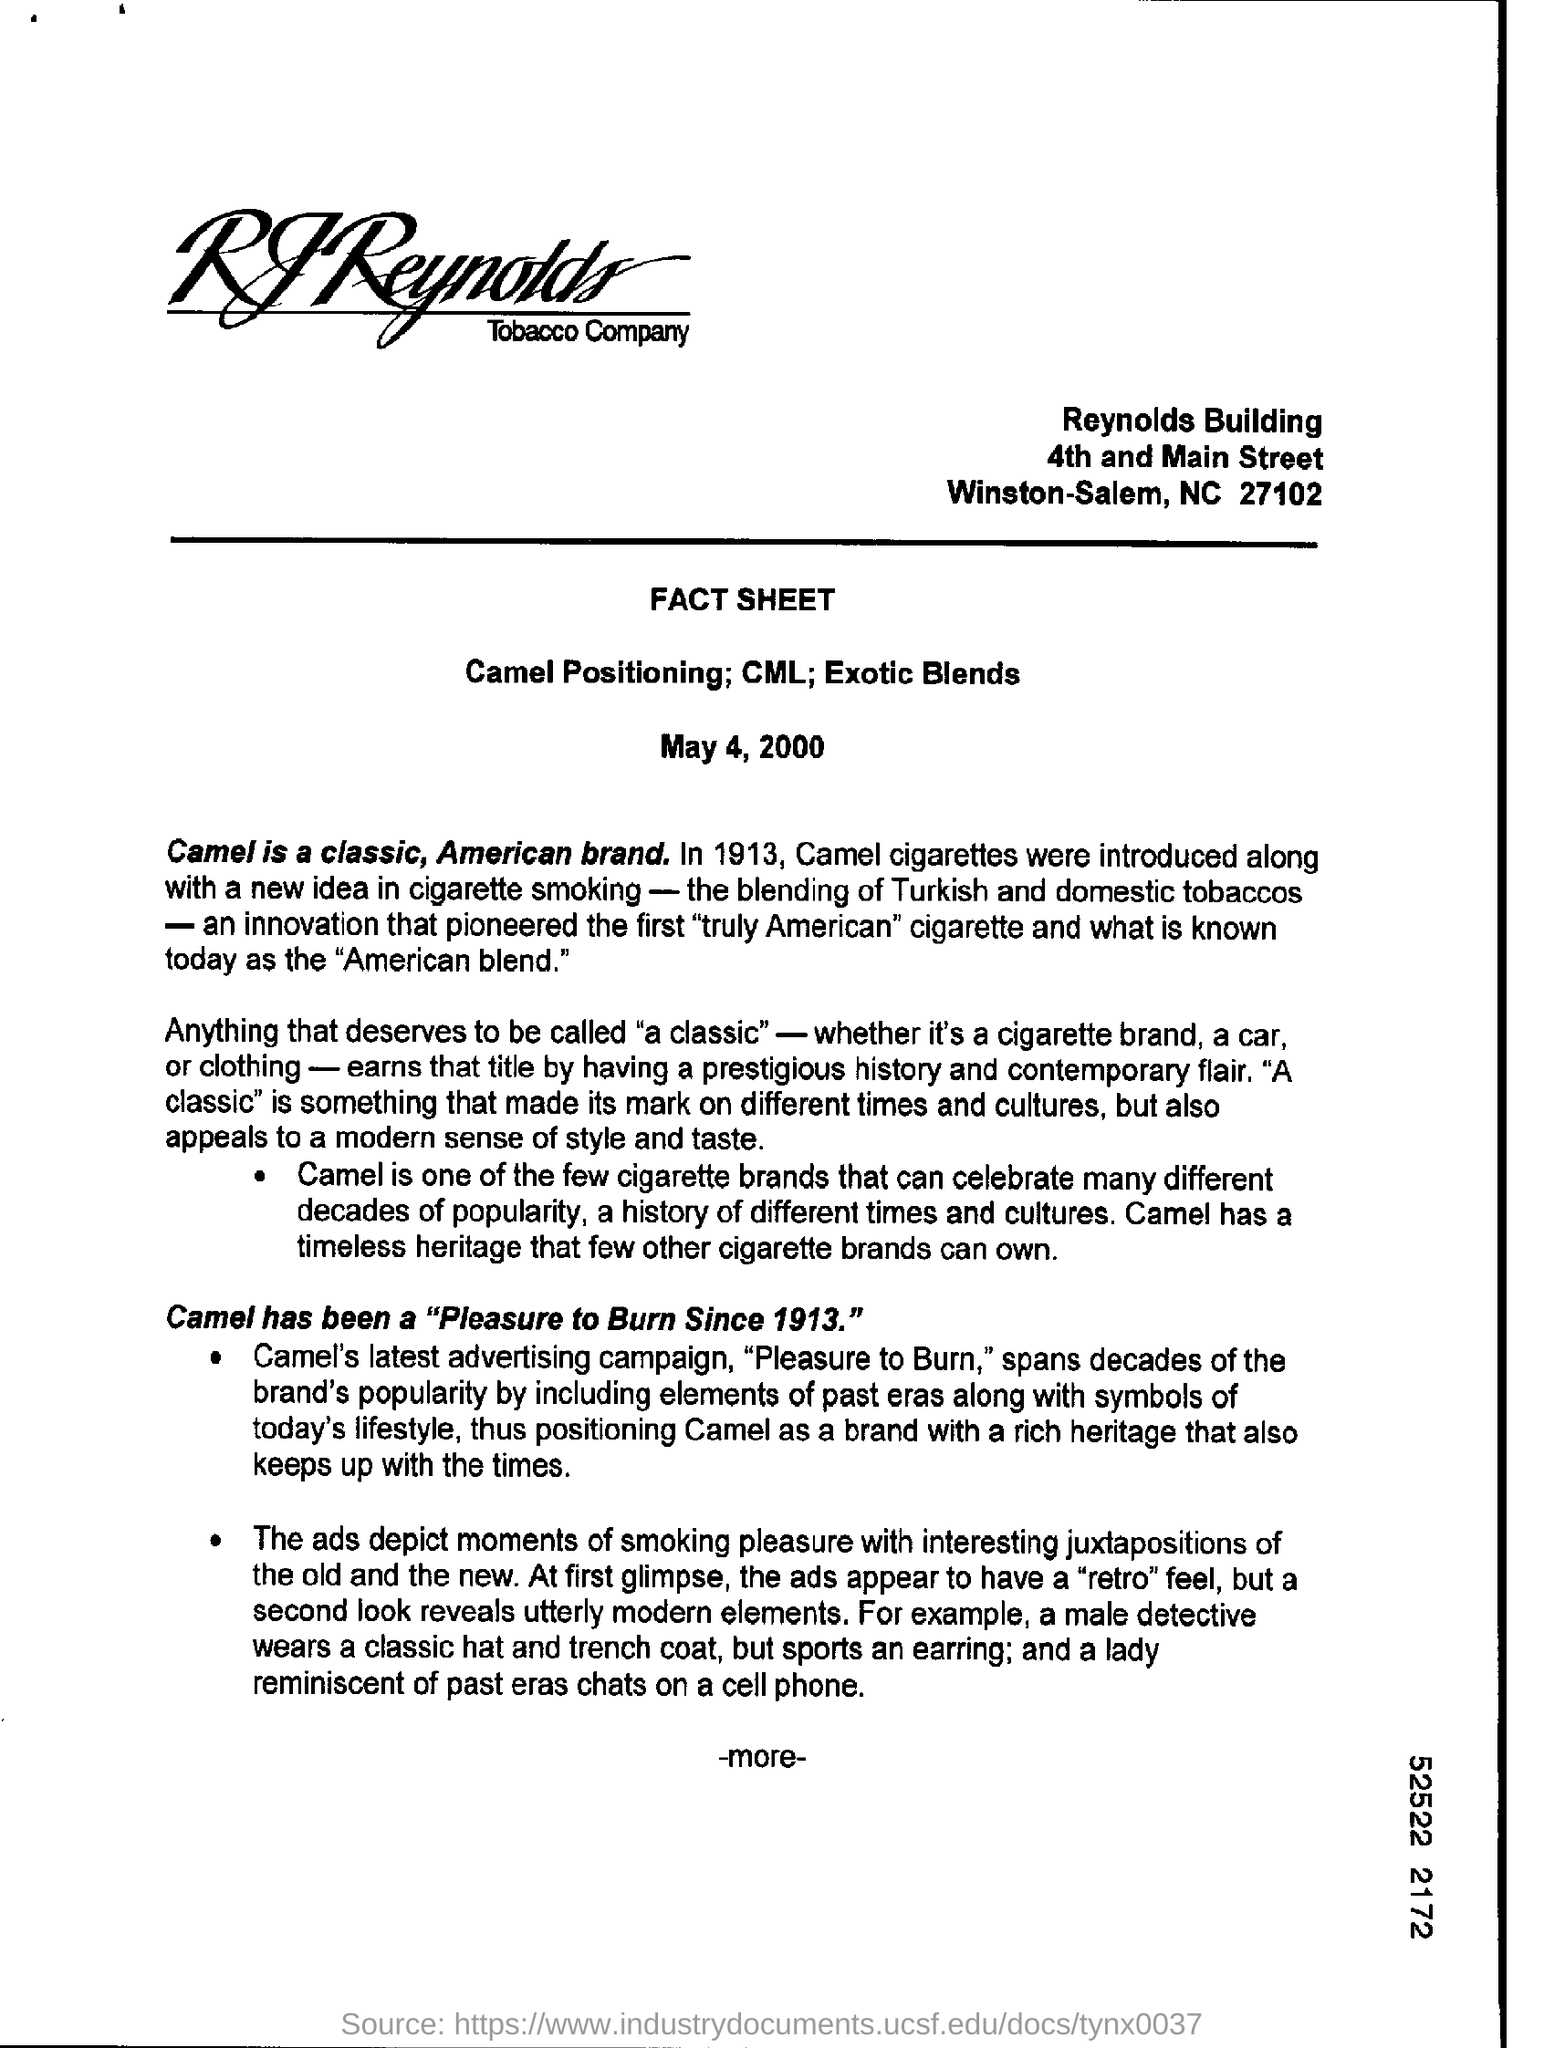List a handful of essential elements in this visual. The given text is a question asking for information about a date mentioned in a particular context. The Reynolds Building is the first line of the address mentioned at the top. 